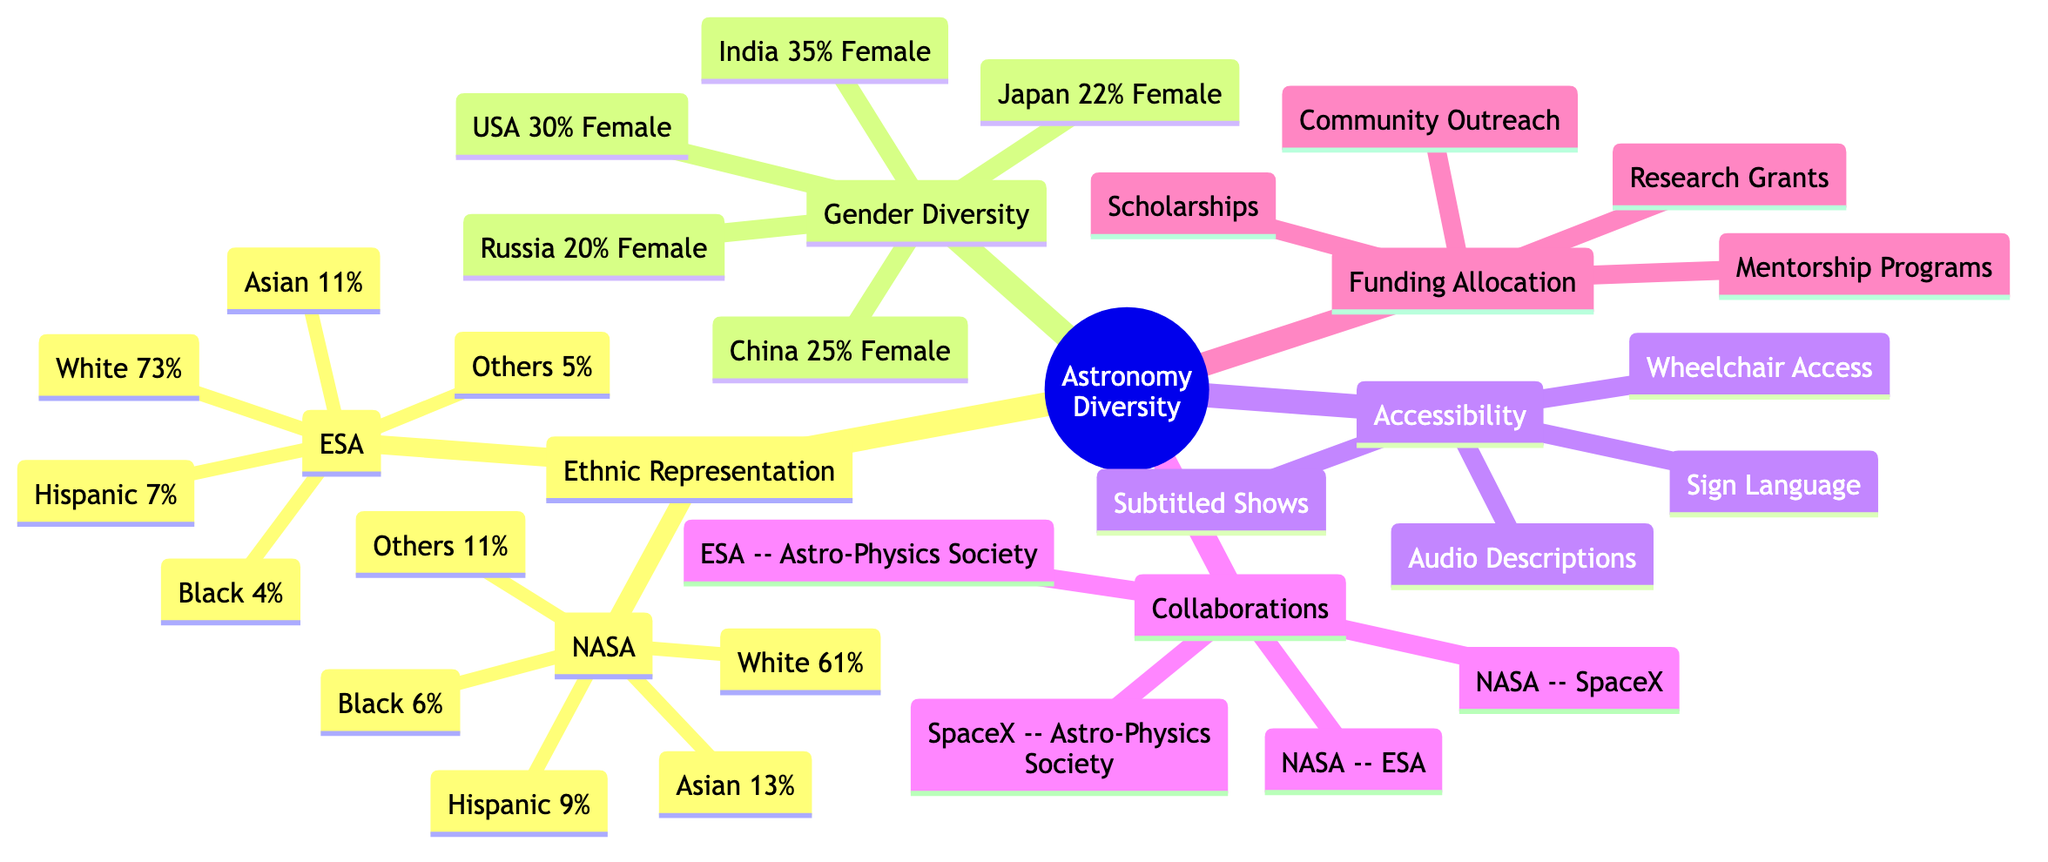What's the percentage of Black representation in NASA? The diagram shows that Black representation in NASA is listed as 6%, directly taken from the ethnic representation section of the diagram for NASA.
Answer: 6% What are the countries mentioned in the Gender Diversity section? The Gender Diversity section includes five countries: USA, Russia, China, India, and Japan. These are specifically labeled in the diagram.
Answer: USA, Russia, China, India, Japan Which organization has the highest percentage of White employees? In the representation of different ethnic groups, ESA has the highest percentage of White employees at 73%. This can be found by comparing the percentages across organizations labeled in the ethnic representation section.
Answer: 73% How many types of accessibility features are listed in the Accessibility section? The Accessibility section lists four specific features: Audio Descriptions, Sign Language, Wheelchair Access, and Subtitled Shows. Counting these gives a total of four types of features.
Answer: 4 Which collaboration exists between NASA and SpaceX? The diagram indicates a collaboration between NASA and SpaceX in the Collaborations section, explicitly labeled as such.
Answer: NASA -- SpaceX What is the female participation percentage in India? India has a female participation percentage of 35%, as noted in the Gender Diversity section of the diagram. This is a single data point directly stated for India.
Answer: 35% What types of programs are listed in the Funding Allocation section? The Funding Allocation section includes mentorship programs, scholarships, community outreach, and research grants. These are explicitly listed in the diagram.
Answer: Mentorship Programs, Scholarships, Community Outreach, Research Grants Which organization has the lowest percentage of Hispanic representation? ESA has the lowest percentage of Hispanic representation at 7%, compared to NASA which has 9%. This is determined by comparing the percentages of Hispanic representation in both organizations in the ethnic representation section.
Answer: 7% What type of diagram shows the Network of Collaborations? The diagram type used to show the network of collaborations is a node-link diagram, specifically designed to display relationships and connections between different nodes efficiently.
Answer: Node-link diagram 